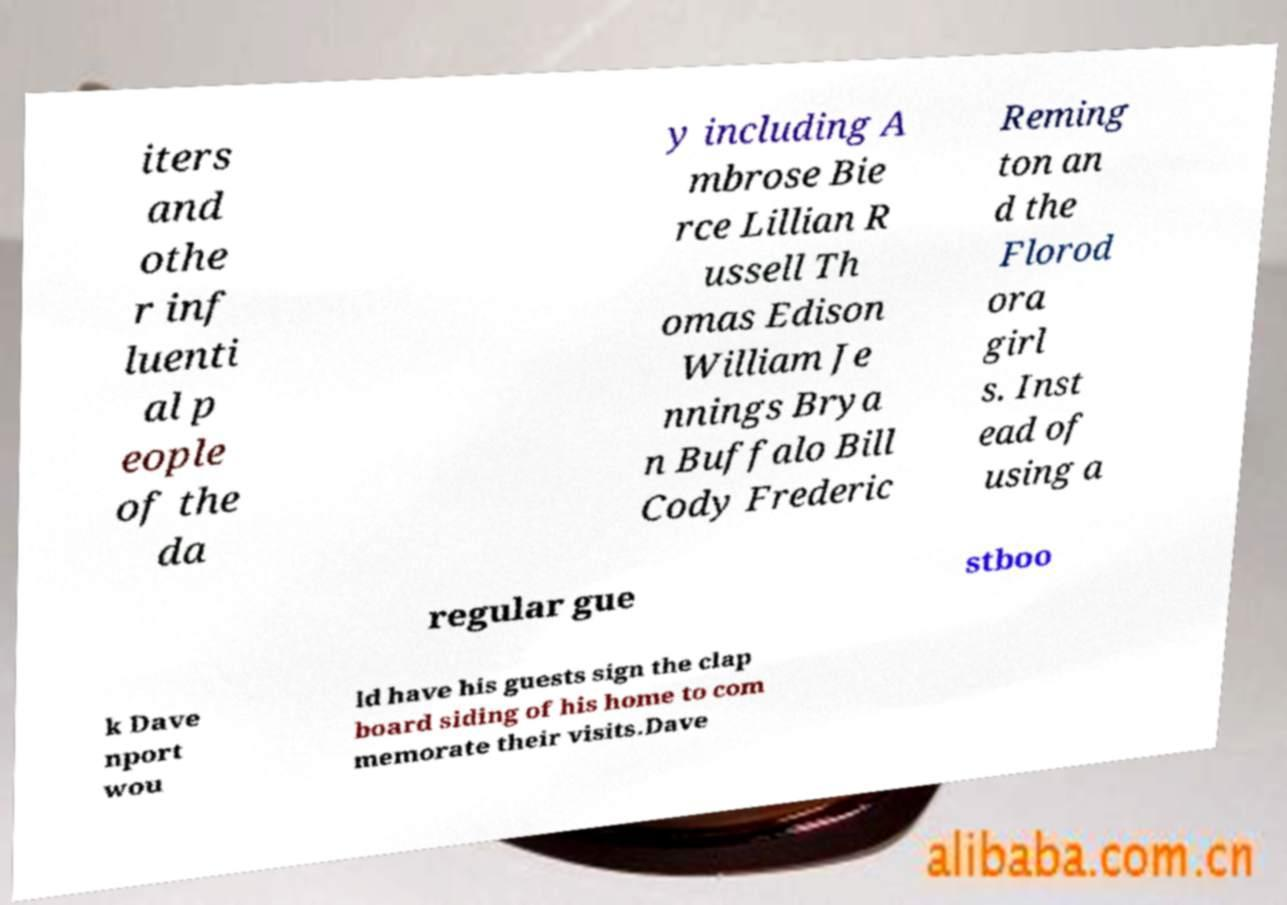Please identify and transcribe the text found in this image. iters and othe r inf luenti al p eople of the da y including A mbrose Bie rce Lillian R ussell Th omas Edison William Je nnings Brya n Buffalo Bill Cody Frederic Reming ton an d the Florod ora girl s. Inst ead of using a regular gue stboo k Dave nport wou ld have his guests sign the clap board siding of his home to com memorate their visits.Dave 